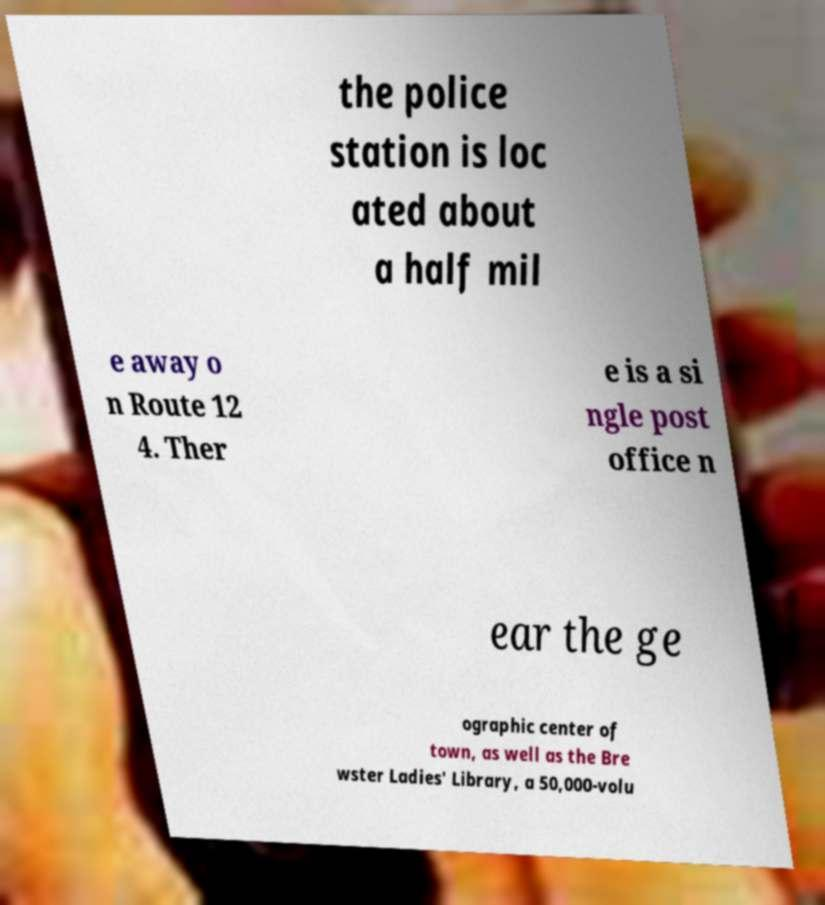Please read and relay the text visible in this image. What does it say? the police station is loc ated about a half mil e away o n Route 12 4. Ther e is a si ngle post office n ear the ge ographic center of town, as well as the Bre wster Ladies' Library, a 50,000-volu 